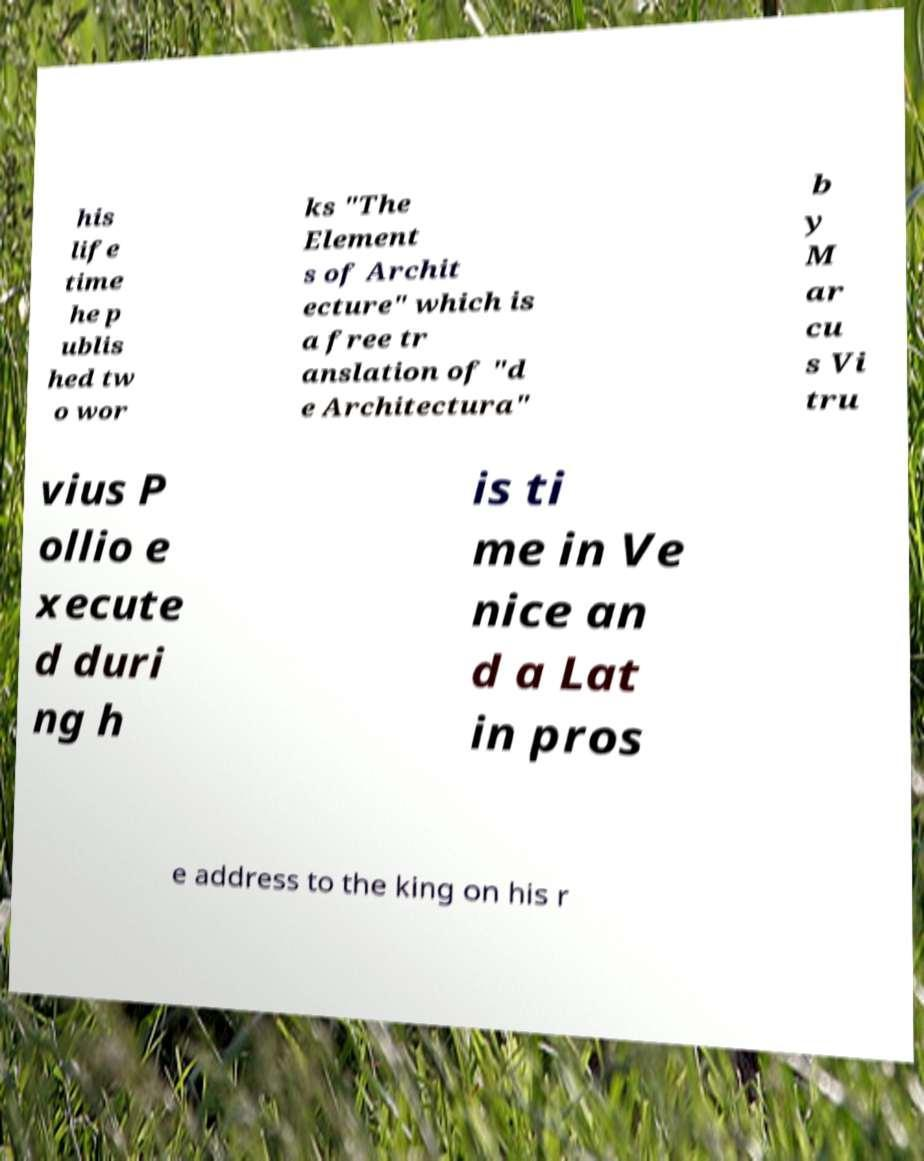There's text embedded in this image that I need extracted. Can you transcribe it verbatim? his life time he p ublis hed tw o wor ks "The Element s of Archit ecture" which is a free tr anslation of "d e Architectura" b y M ar cu s Vi tru vius P ollio e xecute d duri ng h is ti me in Ve nice an d a Lat in pros e address to the king on his r 